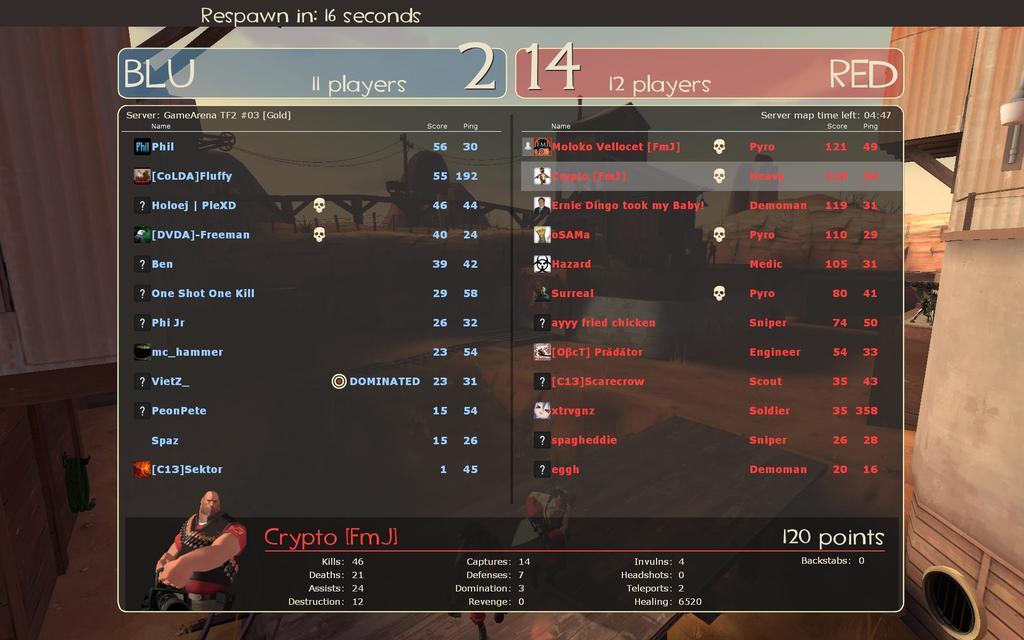How many players are on the red team?
Your response must be concise. 12. He will re spawn in how much time?
Make the answer very short. 16 seconds. 